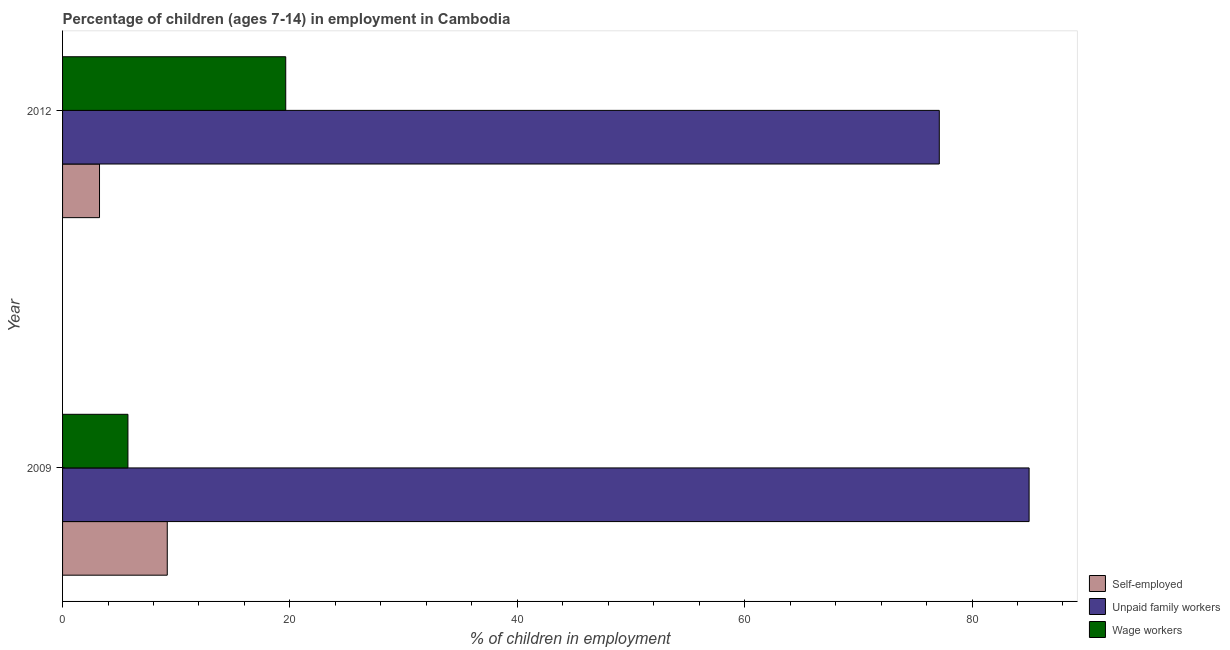How many different coloured bars are there?
Give a very brief answer. 3. Are the number of bars per tick equal to the number of legend labels?
Provide a short and direct response. Yes. Are the number of bars on each tick of the Y-axis equal?
Your answer should be compact. Yes. How many bars are there on the 2nd tick from the top?
Offer a terse response. 3. How many bars are there on the 1st tick from the bottom?
Offer a terse response. 3. What is the percentage of children employed as wage workers in 2009?
Keep it short and to the point. 5.75. Across all years, what is the maximum percentage of self employed children?
Ensure brevity in your answer.  9.21. Across all years, what is the minimum percentage of children employed as unpaid family workers?
Your answer should be very brief. 77.12. In which year was the percentage of self employed children minimum?
Keep it short and to the point. 2012. What is the total percentage of self employed children in the graph?
Offer a very short reply. 12.46. What is the difference between the percentage of children employed as unpaid family workers in 2009 and the percentage of children employed as wage workers in 2012?
Offer a terse response. 65.39. What is the average percentage of children employed as wage workers per year?
Your answer should be very brief. 12.69. In the year 2012, what is the difference between the percentage of self employed children and percentage of children employed as wage workers?
Keep it short and to the point. -16.38. In how many years, is the percentage of children employed as unpaid family workers greater than 12 %?
Give a very brief answer. 2. What is the ratio of the percentage of children employed as wage workers in 2009 to that in 2012?
Provide a succinct answer. 0.29. Is the percentage of self employed children in 2009 less than that in 2012?
Provide a short and direct response. No. In how many years, is the percentage of children employed as unpaid family workers greater than the average percentage of children employed as unpaid family workers taken over all years?
Give a very brief answer. 1. What does the 1st bar from the top in 2012 represents?
Give a very brief answer. Wage workers. What does the 3rd bar from the bottom in 2012 represents?
Offer a very short reply. Wage workers. Are all the bars in the graph horizontal?
Provide a short and direct response. Yes. How many years are there in the graph?
Offer a very short reply. 2. What is the difference between two consecutive major ticks on the X-axis?
Make the answer very short. 20. Does the graph contain any zero values?
Your answer should be compact. No. Does the graph contain grids?
Ensure brevity in your answer.  No. How many legend labels are there?
Provide a short and direct response. 3. How are the legend labels stacked?
Provide a short and direct response. Vertical. What is the title of the graph?
Give a very brief answer. Percentage of children (ages 7-14) in employment in Cambodia. What is the label or title of the X-axis?
Offer a terse response. % of children in employment. What is the label or title of the Y-axis?
Your response must be concise. Year. What is the % of children in employment of Self-employed in 2009?
Offer a very short reply. 9.21. What is the % of children in employment in Unpaid family workers in 2009?
Make the answer very short. 85.02. What is the % of children in employment of Wage workers in 2009?
Offer a terse response. 5.75. What is the % of children in employment in Unpaid family workers in 2012?
Keep it short and to the point. 77.12. What is the % of children in employment of Wage workers in 2012?
Ensure brevity in your answer.  19.63. Across all years, what is the maximum % of children in employment in Self-employed?
Offer a very short reply. 9.21. Across all years, what is the maximum % of children in employment in Unpaid family workers?
Your answer should be compact. 85.02. Across all years, what is the maximum % of children in employment in Wage workers?
Provide a short and direct response. 19.63. Across all years, what is the minimum % of children in employment of Unpaid family workers?
Keep it short and to the point. 77.12. Across all years, what is the minimum % of children in employment of Wage workers?
Offer a terse response. 5.75. What is the total % of children in employment of Self-employed in the graph?
Give a very brief answer. 12.46. What is the total % of children in employment of Unpaid family workers in the graph?
Provide a succinct answer. 162.14. What is the total % of children in employment of Wage workers in the graph?
Provide a short and direct response. 25.38. What is the difference between the % of children in employment in Self-employed in 2009 and that in 2012?
Offer a very short reply. 5.96. What is the difference between the % of children in employment in Unpaid family workers in 2009 and that in 2012?
Make the answer very short. 7.9. What is the difference between the % of children in employment of Wage workers in 2009 and that in 2012?
Provide a short and direct response. -13.88. What is the difference between the % of children in employment of Self-employed in 2009 and the % of children in employment of Unpaid family workers in 2012?
Provide a succinct answer. -67.91. What is the difference between the % of children in employment in Self-employed in 2009 and the % of children in employment in Wage workers in 2012?
Your answer should be very brief. -10.42. What is the difference between the % of children in employment of Unpaid family workers in 2009 and the % of children in employment of Wage workers in 2012?
Your response must be concise. 65.39. What is the average % of children in employment of Self-employed per year?
Provide a succinct answer. 6.23. What is the average % of children in employment of Unpaid family workers per year?
Provide a short and direct response. 81.07. What is the average % of children in employment of Wage workers per year?
Ensure brevity in your answer.  12.69. In the year 2009, what is the difference between the % of children in employment in Self-employed and % of children in employment in Unpaid family workers?
Give a very brief answer. -75.81. In the year 2009, what is the difference between the % of children in employment in Self-employed and % of children in employment in Wage workers?
Make the answer very short. 3.46. In the year 2009, what is the difference between the % of children in employment of Unpaid family workers and % of children in employment of Wage workers?
Provide a short and direct response. 79.27. In the year 2012, what is the difference between the % of children in employment of Self-employed and % of children in employment of Unpaid family workers?
Your answer should be very brief. -73.87. In the year 2012, what is the difference between the % of children in employment in Self-employed and % of children in employment in Wage workers?
Provide a succinct answer. -16.38. In the year 2012, what is the difference between the % of children in employment in Unpaid family workers and % of children in employment in Wage workers?
Make the answer very short. 57.49. What is the ratio of the % of children in employment in Self-employed in 2009 to that in 2012?
Ensure brevity in your answer.  2.83. What is the ratio of the % of children in employment in Unpaid family workers in 2009 to that in 2012?
Provide a succinct answer. 1.1. What is the ratio of the % of children in employment in Wage workers in 2009 to that in 2012?
Offer a terse response. 0.29. What is the difference between the highest and the second highest % of children in employment in Self-employed?
Your answer should be very brief. 5.96. What is the difference between the highest and the second highest % of children in employment of Unpaid family workers?
Give a very brief answer. 7.9. What is the difference between the highest and the second highest % of children in employment of Wage workers?
Provide a short and direct response. 13.88. What is the difference between the highest and the lowest % of children in employment of Self-employed?
Give a very brief answer. 5.96. What is the difference between the highest and the lowest % of children in employment in Unpaid family workers?
Keep it short and to the point. 7.9. What is the difference between the highest and the lowest % of children in employment of Wage workers?
Provide a short and direct response. 13.88. 